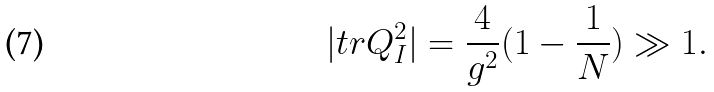Convert formula to latex. <formula><loc_0><loc_0><loc_500><loc_500>| t r Q _ { I } ^ { 2 } | = \frac { 4 } { g ^ { 2 } } ( 1 - \frac { 1 } { N } ) \gg 1 .</formula> 